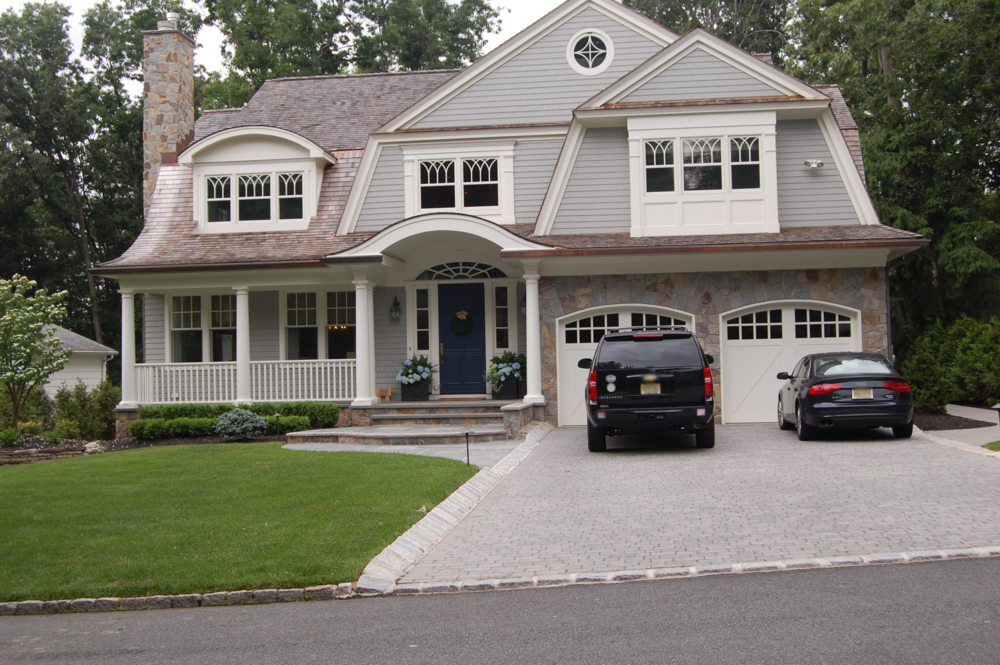Imagine if this house were set in a tropical location. How might its design elements be adapted to suit that environment? In a tropical setting, the design of this Craftsman-style house could be adapted to better suit the climate and aesthetic of the surroundings. The use of lighter materials such as bamboo or other sustainable woods could replace some of the heavier stone elements to keep the house cool. The color palette might shift to include more vibrant tones, such as teal or coral, to reflect the tropical ambiance. Additionally, larger windows and open spaces could be incorporated to allow for better airflow and natural light, essential in humid climates. The covered porch might be transformed into a more open, breezy veranda, perfect for enjoying the tropical weather. What other changes to the landscaping might enhance the tropical feel? To enhance the tropical feel, the landscaping could be transformed with lush greenery and vibrant flowers. Planting palm trees, hibiscus, and other tropical plants would add to the ambiance. Installing a small water feature, such as a pond or a waterfall, could create a tranquil atmosphere. Pathways could be lined with exotic blooms and edged with decorative stones or shells. Adding a few hammocks or outdoor seating areas under the shade of some large trees would complete the tropical feel, inviting relaxation and the enjoyment of the beautiful surroundings. 